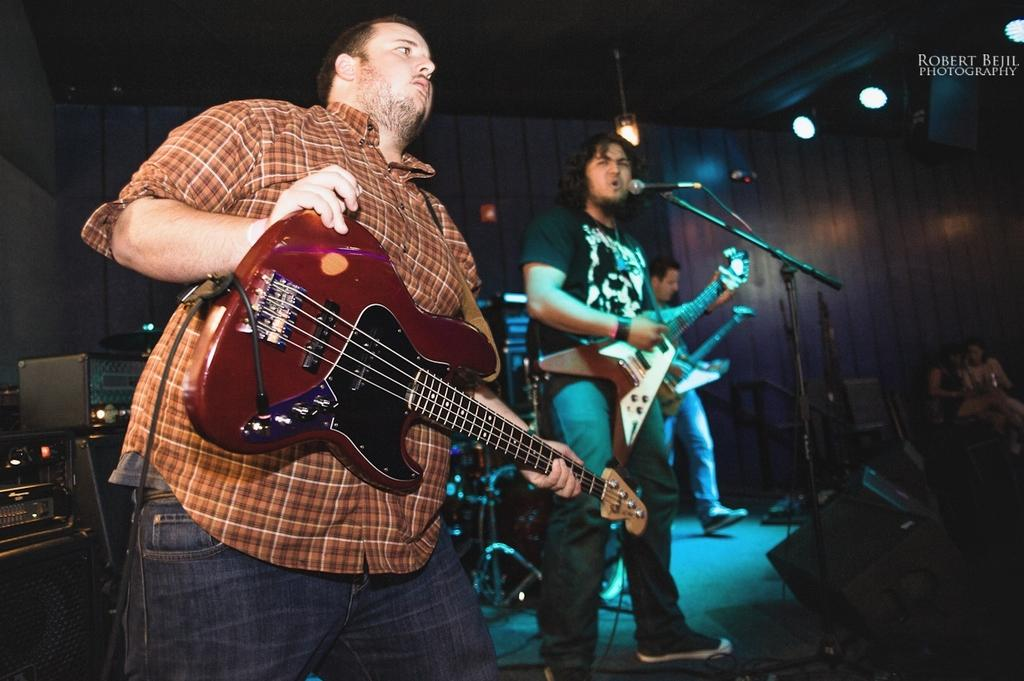What type of performance is taking place in the image? There is a rock band performing in the image. Where is the performance taking place? The performance is taking place in a concert. What type of chalk is being used by the band members during the performance? There is no chalk present in the image, and therefore no such activity can be observed. 